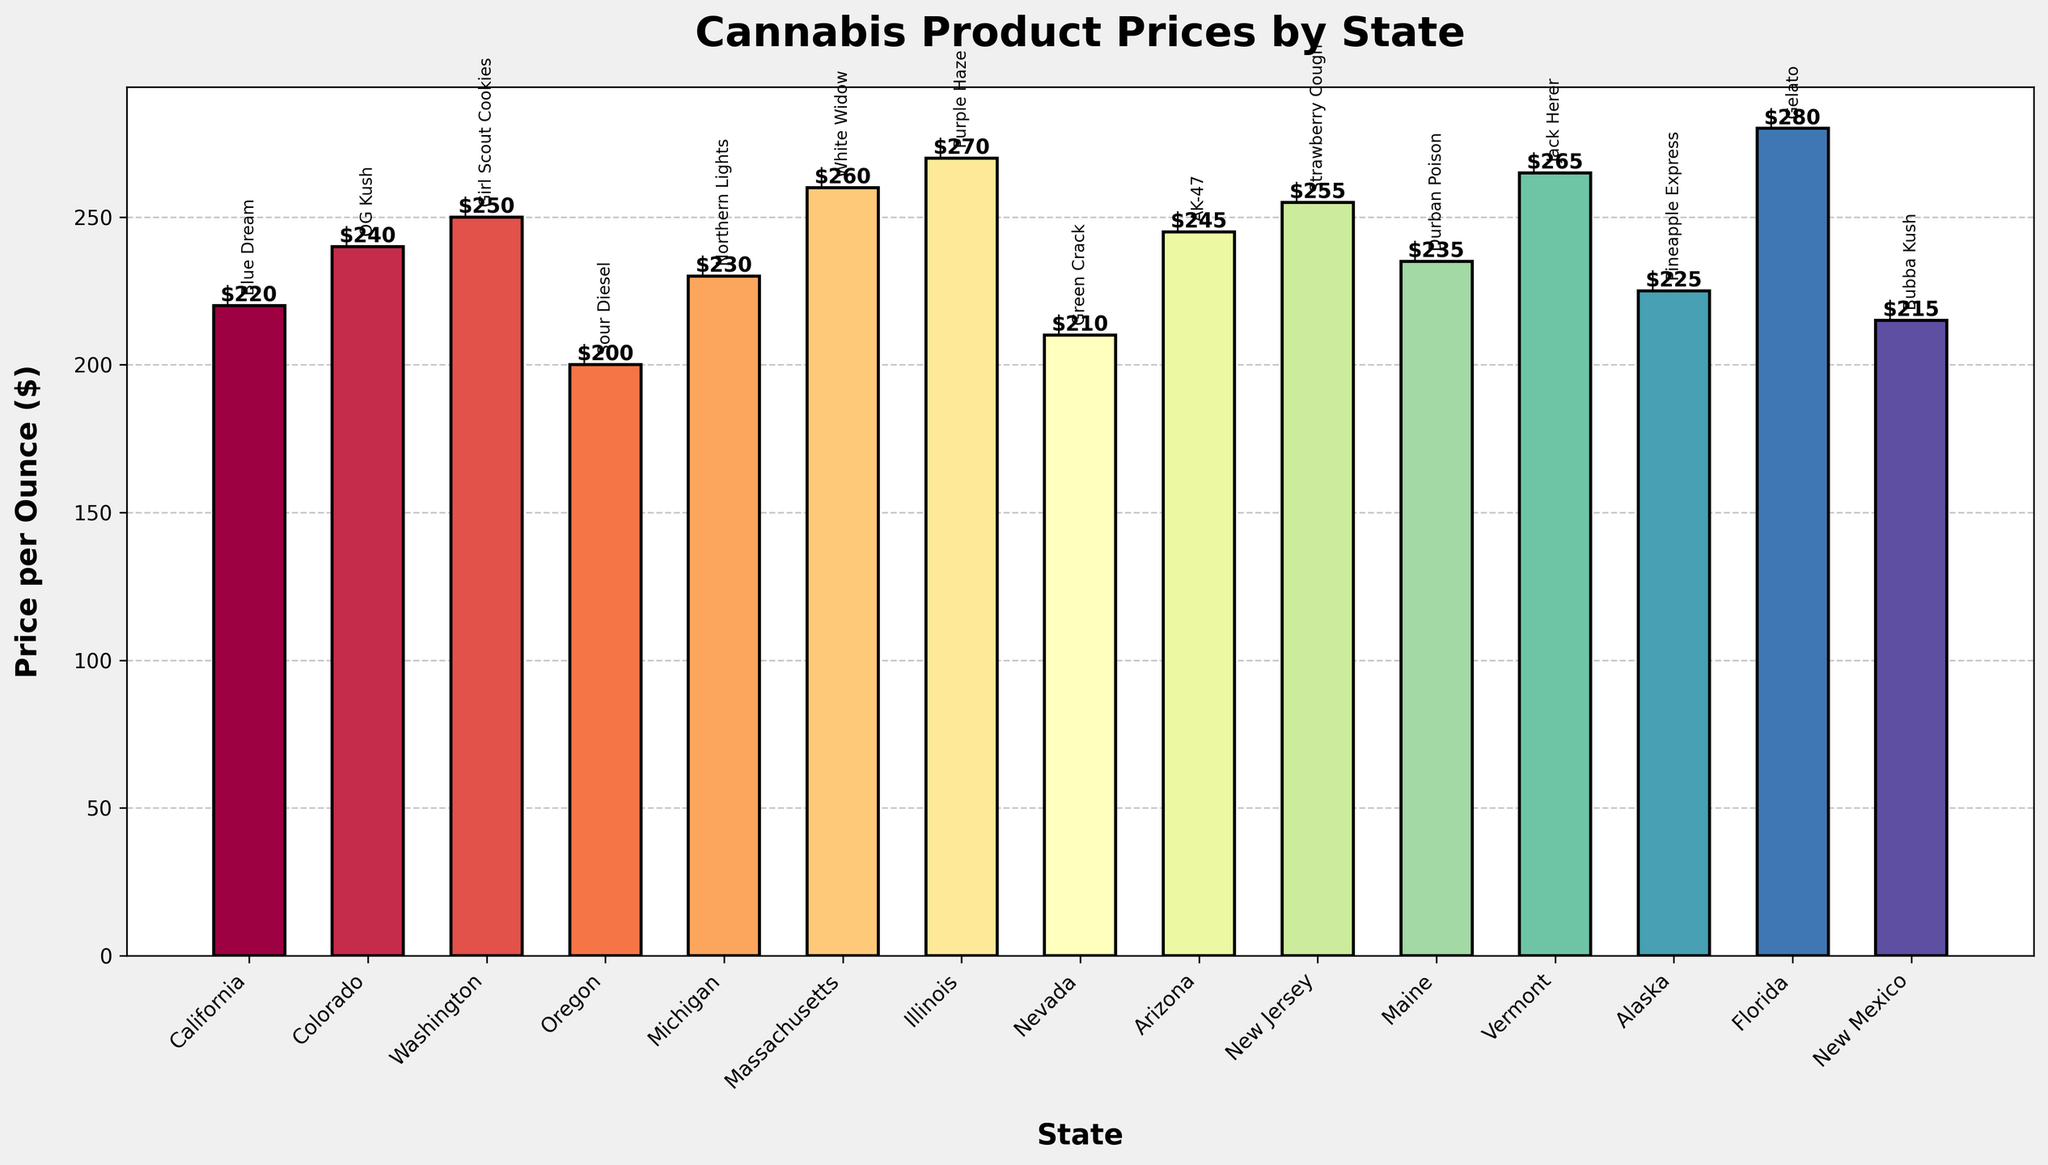Which state has the highest price per ounce for cannabis products? Looking at the tallest bar in the chart, the state with the highest price per ounce is Florida.
Answer: Florida Which two states have the closest price per ounce for their cannabis products? By comparing the heights of the bars, the bars for Arizona (AK-47) and Colorado (OG Kush) appear to be close in height.
Answer: Arizona and Colorado What is the average price per ounce across all states? Sum all the prices and divide by the number of states: (220 + 240 + 250 + 200 + 230 + 260 + 270 + 210 + 245 + 255 + 235 + 265 + 225 + 280 + 215)/15 = 243
Answer: 243 Between California and Massachusetts, which state has a higher price per ounce and by how much? Compare the heights of the bars for California (220) and Massachusetts (260). The difference is 260 - 220 = 40.
Answer: Massachusetts by $40 Are there more states with prices above $250 or below $250? Count the number of bars above and below $250 respectively. Above $250: Massachusetts, Illinois, New Jersey, Vermont, Florida (5 states). Below $250: California, Colorado, Washington, Oregon, Michigan, Nevada, Arizona, Maine, Alaska, New Mexico (10 states).
Answer: Below $250 Which products are priced exactly $240 or more in their respective states? Identify bars with prices $240 or higher: Colorado (OG Kush), Washington (Girl Scout Cookies), Michigan (Northern Lights), Massachusetts (White Widow), Illinois (Purple Haze), Arizona (AK-47), New Jersey (Strawberry Cough), Vermont (Jack Herer), Florida (Gelato)
Answer: OG Kush, Girl Scout Cookies, Northern Lights, White Widow, Purple Haze, AK-47, Strawberry Cough, Jack Herer, Gelato What are the states with prices per ounce between $200 and $225 inclusive? Identify bars within this price range: California (Blue Dream - $220), Oregon (Sour Diesel - $200), Nevada (Green Crack - $210), Alaska (Pineapple Express - $225), New Mexico (Bubba Kush - $215)
Answer: California, Oregon, Nevada, Alaska, New Mexico Which state has the most expensive cannabis product, and what is it? Find the tallest bar in the plot which is Florida. The product listed is Gelato.
Answer: Gelato in Florida How does the price for cannabis products in Maine compare to those in Alaska? Compare the heights of the bars for Maine (Durban Poison - $235) and Alaska (Pineapple Express - $225). Maine's price is higher.
Answer: Maine is higher by $10 